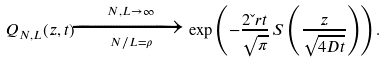Convert formula to latex. <formula><loc_0><loc_0><loc_500><loc_500>Q _ { N , L } ( z , t ) \xrightarrow [ N / L = \rho ] { N , L \rightarrow \infty } \exp \left ( - \frac { 2 \L r t } { \sqrt { \pi } } \, S \left ( \frac { z } { \sqrt { 4 D t } } \right ) \right ) .</formula> 